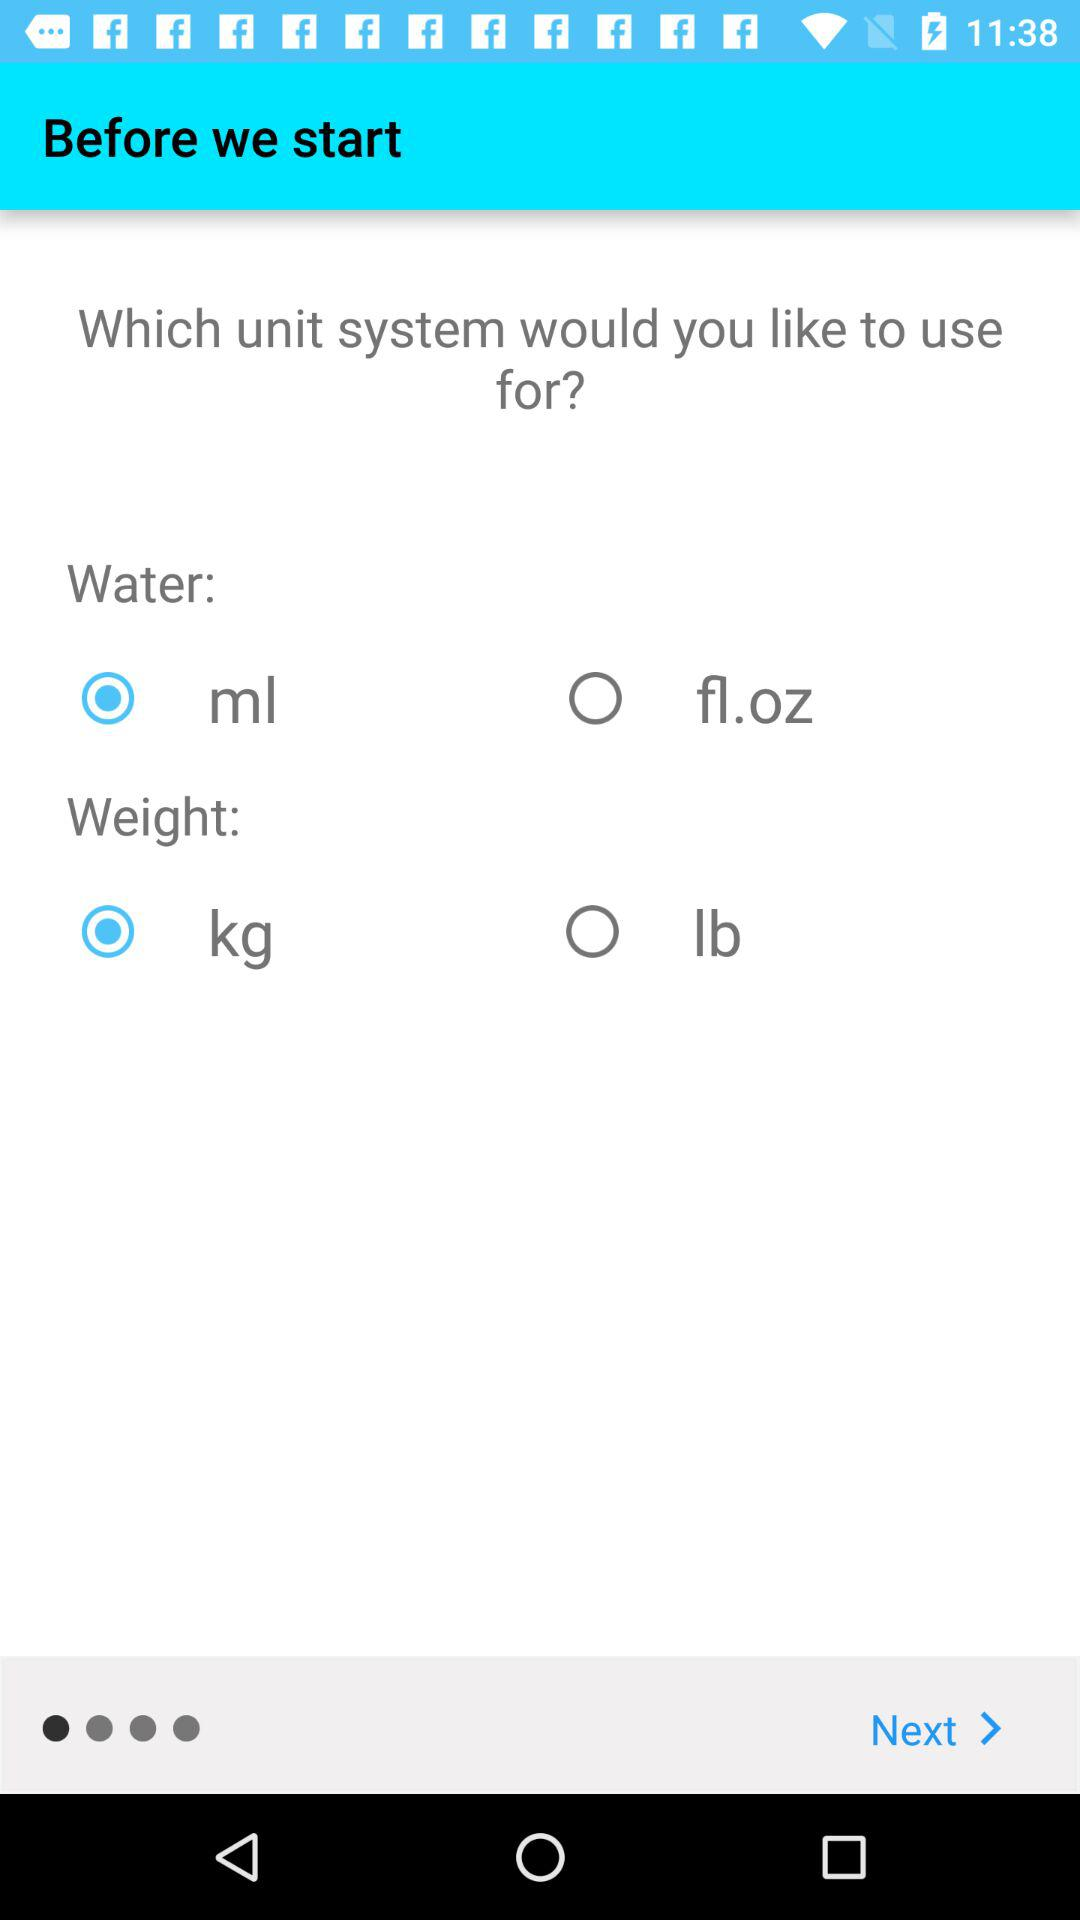Which unit of water is selected to measure? The selected unit of water is "ml". 